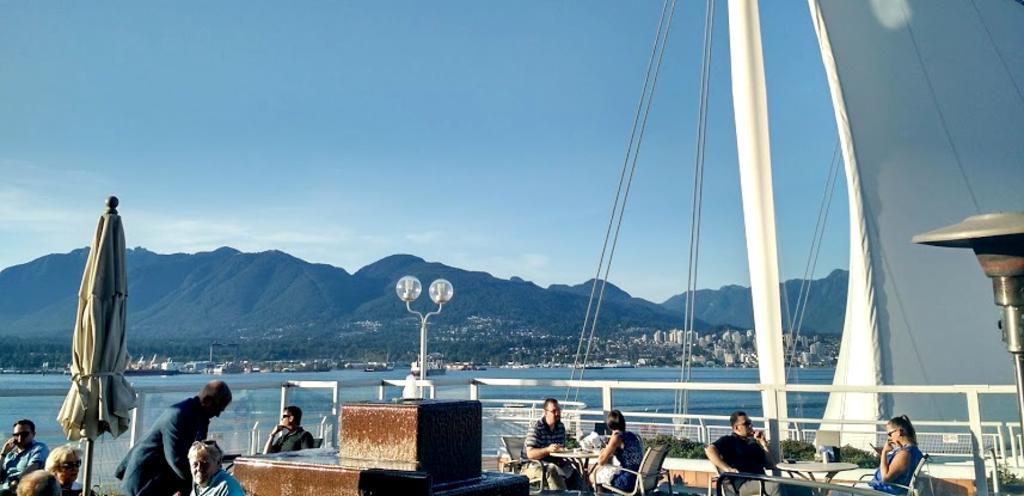In one or two sentences, can you explain what this image depicts? In the foreground of the picture there are tables, chairs, people, umbrella, lights, railing and other objects. In the center of the picture there is a water body. In the background there are trees, buildings and hills. At the top it is sky. 